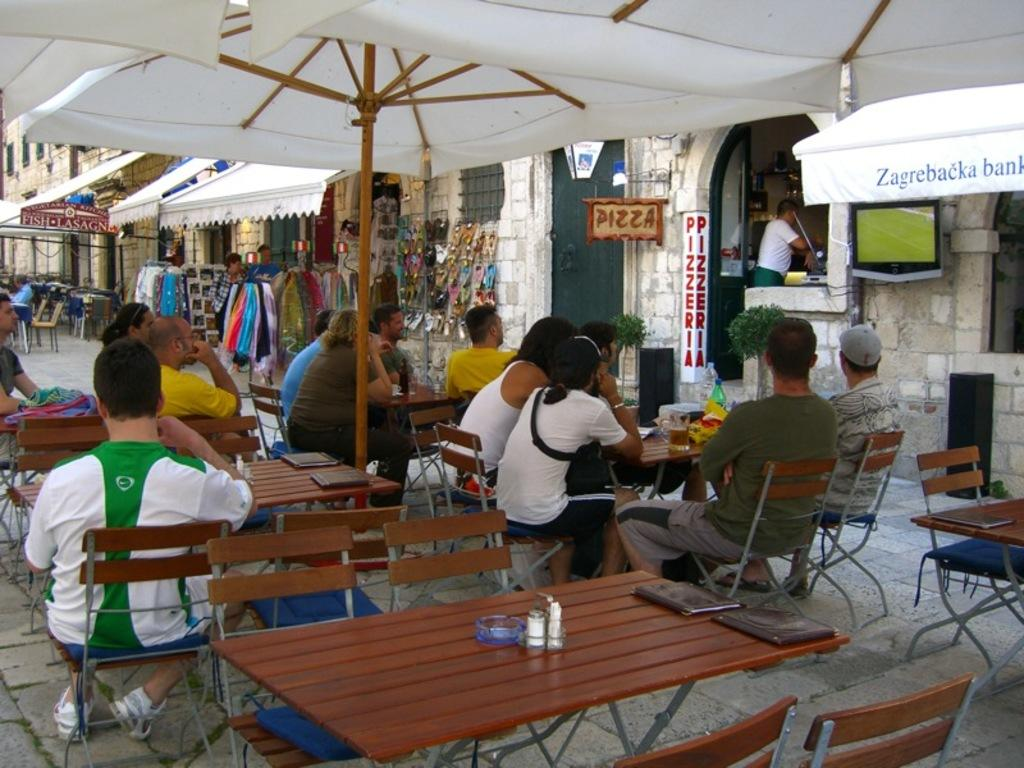Who or what can be seen in the image? There are people in the image. What are the people doing in the image? The people are sitting on chairs. What type of grape is being used as a footrest by one of the people in the image? There is no grape or footrest present in the image; the people are simply sitting on chairs. 